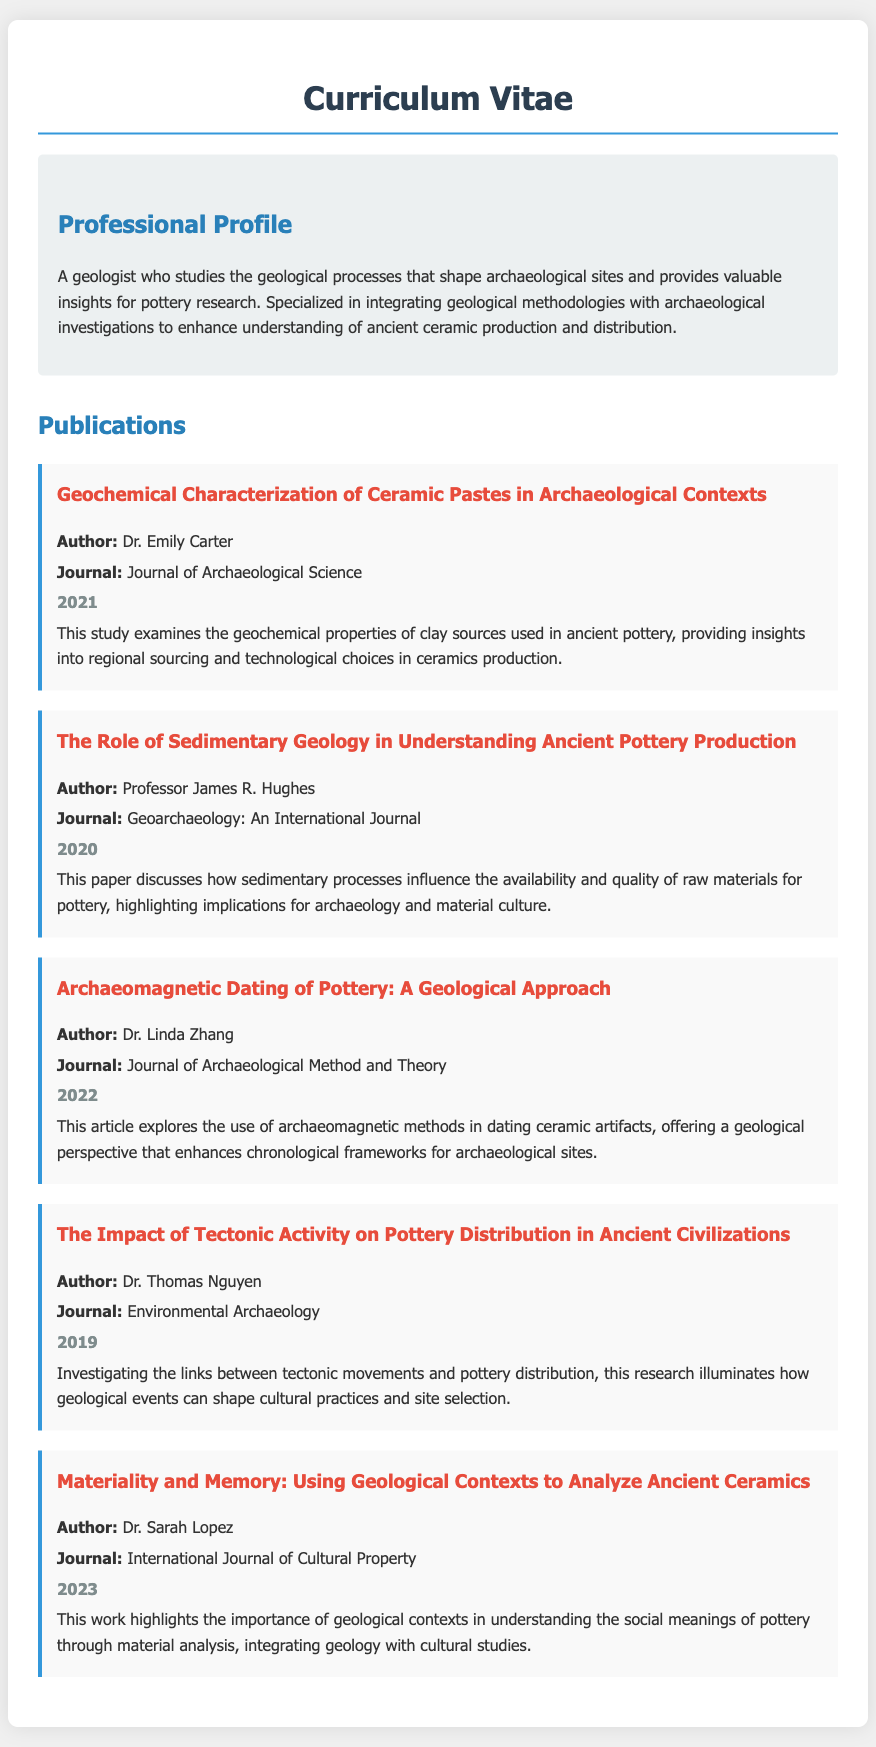What is the title of the publication authored by Dr. Emily Carter? The title is specified under her publication section in the document.
Answer: Geochemical Characterization of Ceramic Pastes in Archaeological Contexts Which journal published the work by Professor James R. Hughes? The journal name is listed in the publication information.
Answer: Geoarchaeology: An International Journal In what year was the article about archaeomagnetic dating published? The year is provided in the publication details for Dr. Linda Zhang's work.
Answer: 2022 Who authored the paper discussing the impact of tectonic activity on pottery distribution? The author’s name is mentioned within the publication section.
Answer: Dr. Thomas Nguyen What is the main focus of Dr. Sarah Lopez's 2023 publication? The focus is found in the summary of her publication.
Answer: Geological contexts and social meanings of pottery How many publications are listed in the CV? The total number of publications can be counted from the document.
Answer: Five What geological approach is discussed in the 2022 publication? The exact approach can be inferred from the title and summary of Dr. Linda Zhang's work.
Answer: Archaeomagnetic Dating What common theme is suggested across the publications regarding pottery? The theme can be deduced by evaluating the summaries of the publications as a whole.
Answer: Geological contexts and pottery analysis 